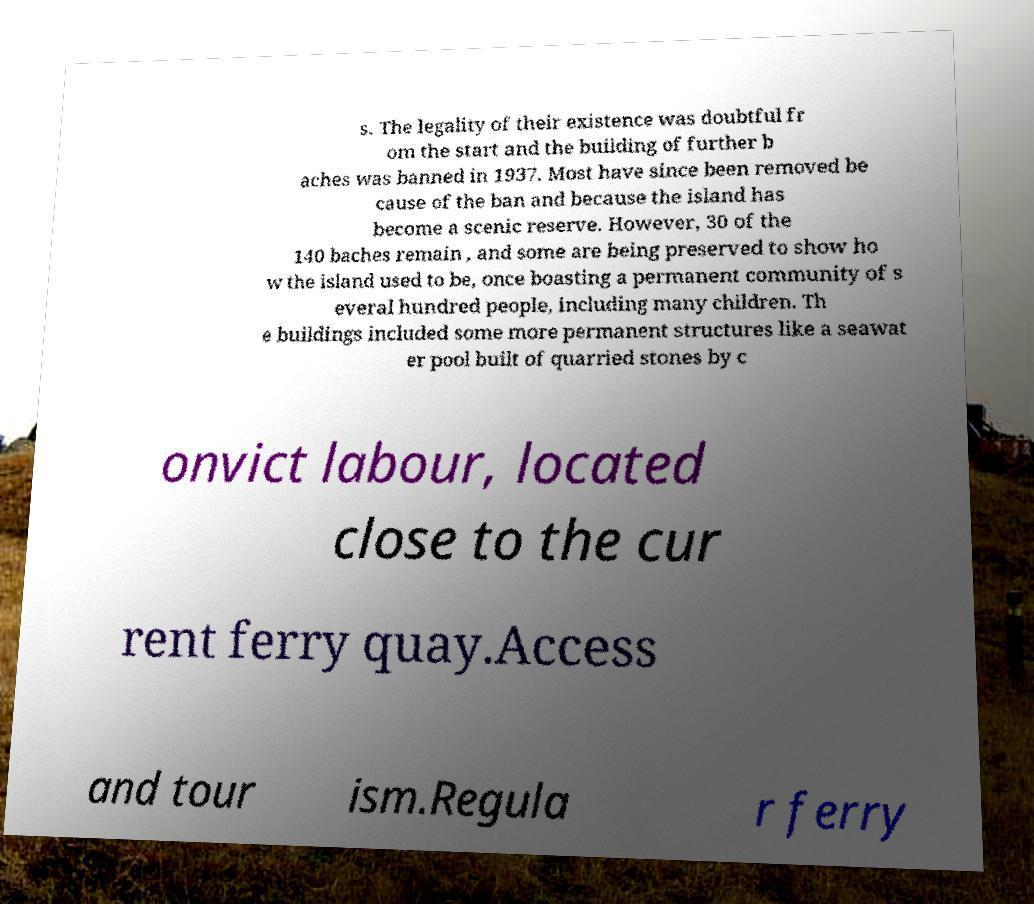Please read and relay the text visible in this image. What does it say? s. The legality of their existence was doubtful fr om the start and the building of further b aches was banned in 1937. Most have since been removed be cause of the ban and because the island has become a scenic reserve. However, 30 of the 140 baches remain , and some are being preserved to show ho w the island used to be, once boasting a permanent community of s everal hundred people, including many children. Th e buildings included some more permanent structures like a seawat er pool built of quarried stones by c onvict labour, located close to the cur rent ferry quay.Access and tour ism.Regula r ferry 